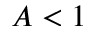Convert formula to latex. <formula><loc_0><loc_0><loc_500><loc_500>A < 1</formula> 